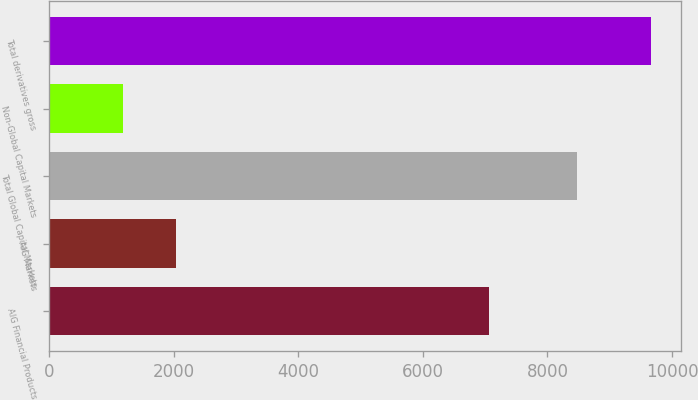Convert chart to OTSL. <chart><loc_0><loc_0><loc_500><loc_500><bar_chart><fcel>AIG Financial Products<fcel>AIG Markets<fcel>Total Global Capital Markets<fcel>Non-Global Capital Markets<fcel>Total derivatives gross<nl><fcel>7063<fcel>2035.2<fcel>8472<fcel>1188<fcel>9660<nl></chart> 